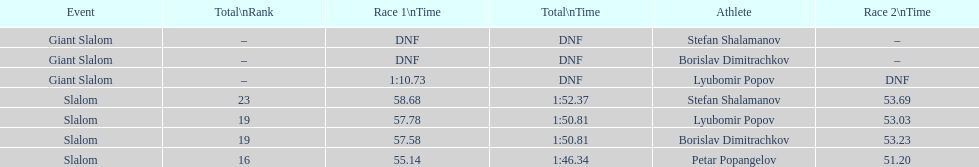What is the difference in time for petar popangelov in race 1and 2 3.94. 